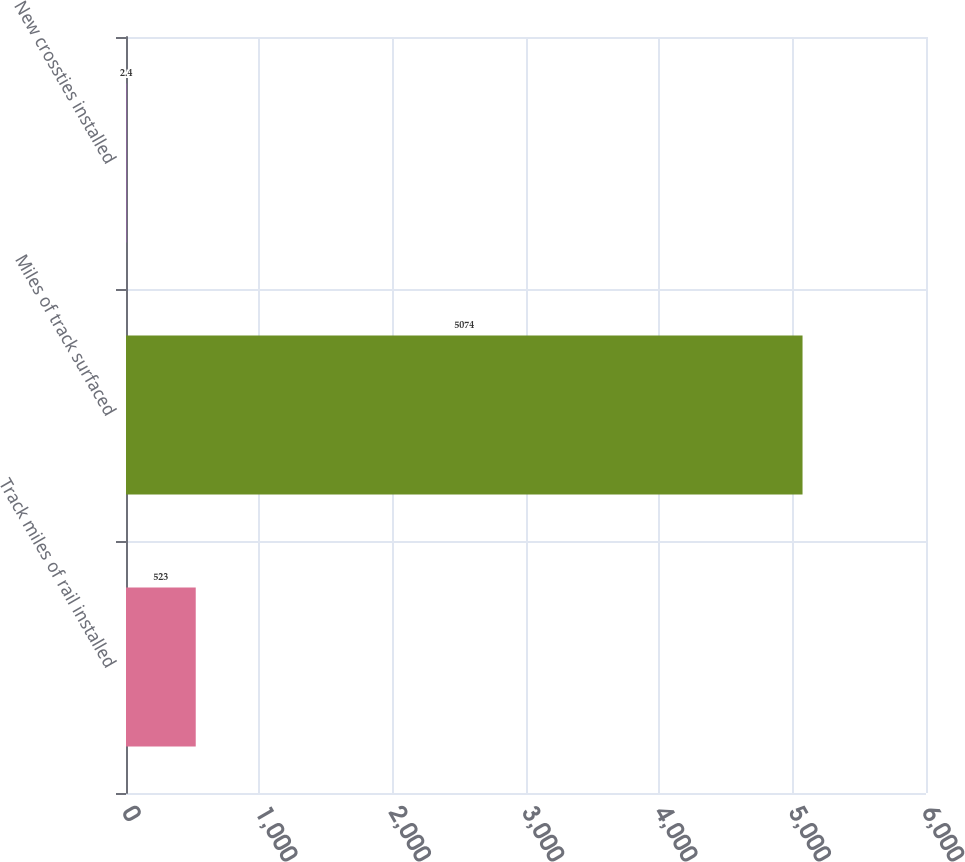Convert chart. <chart><loc_0><loc_0><loc_500><loc_500><bar_chart><fcel>Track miles of rail installed<fcel>Miles of track surfaced<fcel>New crossties installed<nl><fcel>523<fcel>5074<fcel>2.4<nl></chart> 